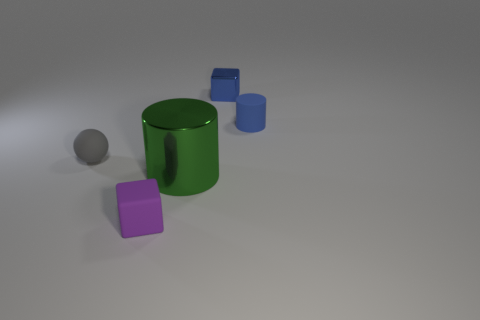Add 4 green metal cylinders. How many objects exist? 9 Subtract all cylinders. How many objects are left? 3 Add 1 large green metallic cylinders. How many large green metallic cylinders exist? 2 Subtract 0 blue balls. How many objects are left? 5 Subtract all cyan blocks. Subtract all gray rubber spheres. How many objects are left? 4 Add 3 small matte cubes. How many small matte cubes are left? 4 